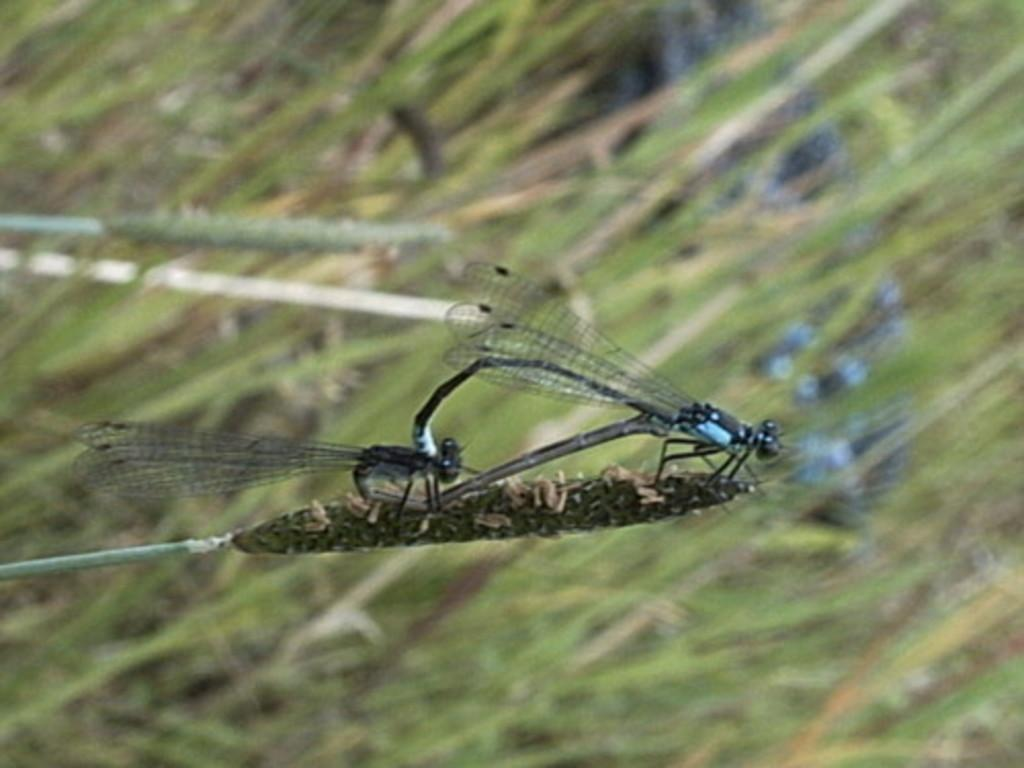What insects can be seen in the image? There are two dragonflies in the image. Where are the dragonflies located in the image? The dragonflies are in the middle of the image. What can be seen in the background of the image? There are plants in the background of the image. What type of hair can be seen on the dragonflies in the image? Dragonflies do not have hair, so there is no hair visible on them in the image. 